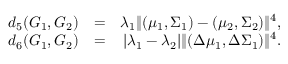<formula> <loc_0><loc_0><loc_500><loc_500>\begin{array} { r l r } { d _ { 5 } ( G _ { 1 } , G _ { 2 } ) } & { = } & { \lambda _ { 1 } \| ( \mu _ { 1 } , \Sigma _ { 1 } ) - ( \mu _ { 2 } , \Sigma _ { 2 } ) \| ^ { 4 } , } \\ { d _ { 6 } ( G _ { 1 } , G _ { 2 } ) } & { = } & { | \lambda _ { 1 } - \lambda _ { 2 } | \| ( \Delta \mu _ { 1 } , \Delta \Sigma _ { 1 } ) \| ^ { 4 } . } \end{array}</formula> 